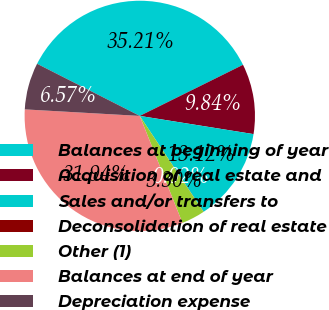<chart> <loc_0><loc_0><loc_500><loc_500><pie_chart><fcel>Balances at beginning of year<fcel>Acquisition of real estate and<fcel>Sales and/or transfers to<fcel>Deconsolidation of real estate<fcel>Other (1)<fcel>Balances at end of year<fcel>Depreciation expense<nl><fcel>35.21%<fcel>9.84%<fcel>13.12%<fcel>0.02%<fcel>3.3%<fcel>31.94%<fcel>6.57%<nl></chart> 